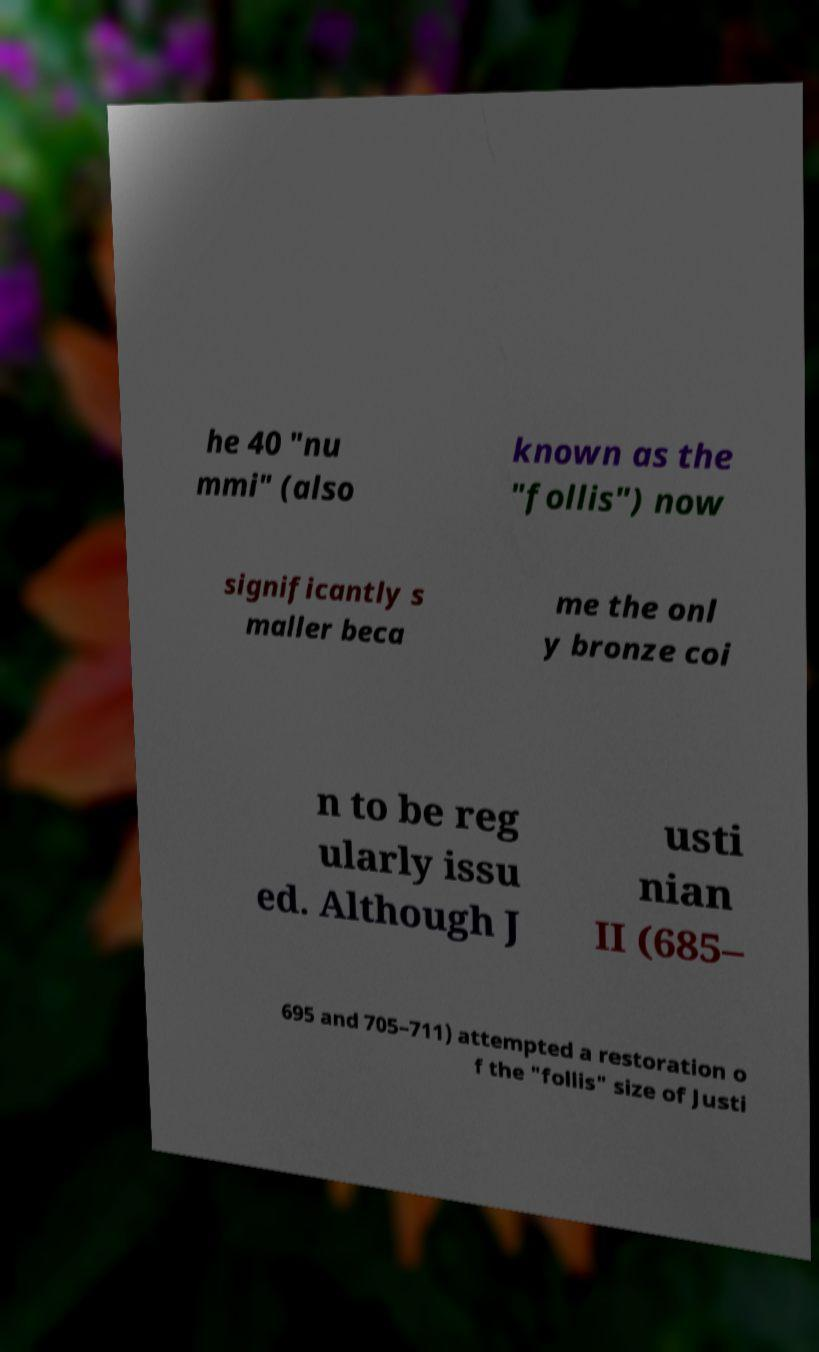I need the written content from this picture converted into text. Can you do that? he 40 "nu mmi" (also known as the "follis") now significantly s maller beca me the onl y bronze coi n to be reg ularly issu ed. Although J usti nian II (685– 695 and 705–711) attempted a restoration o f the "follis" size of Justi 